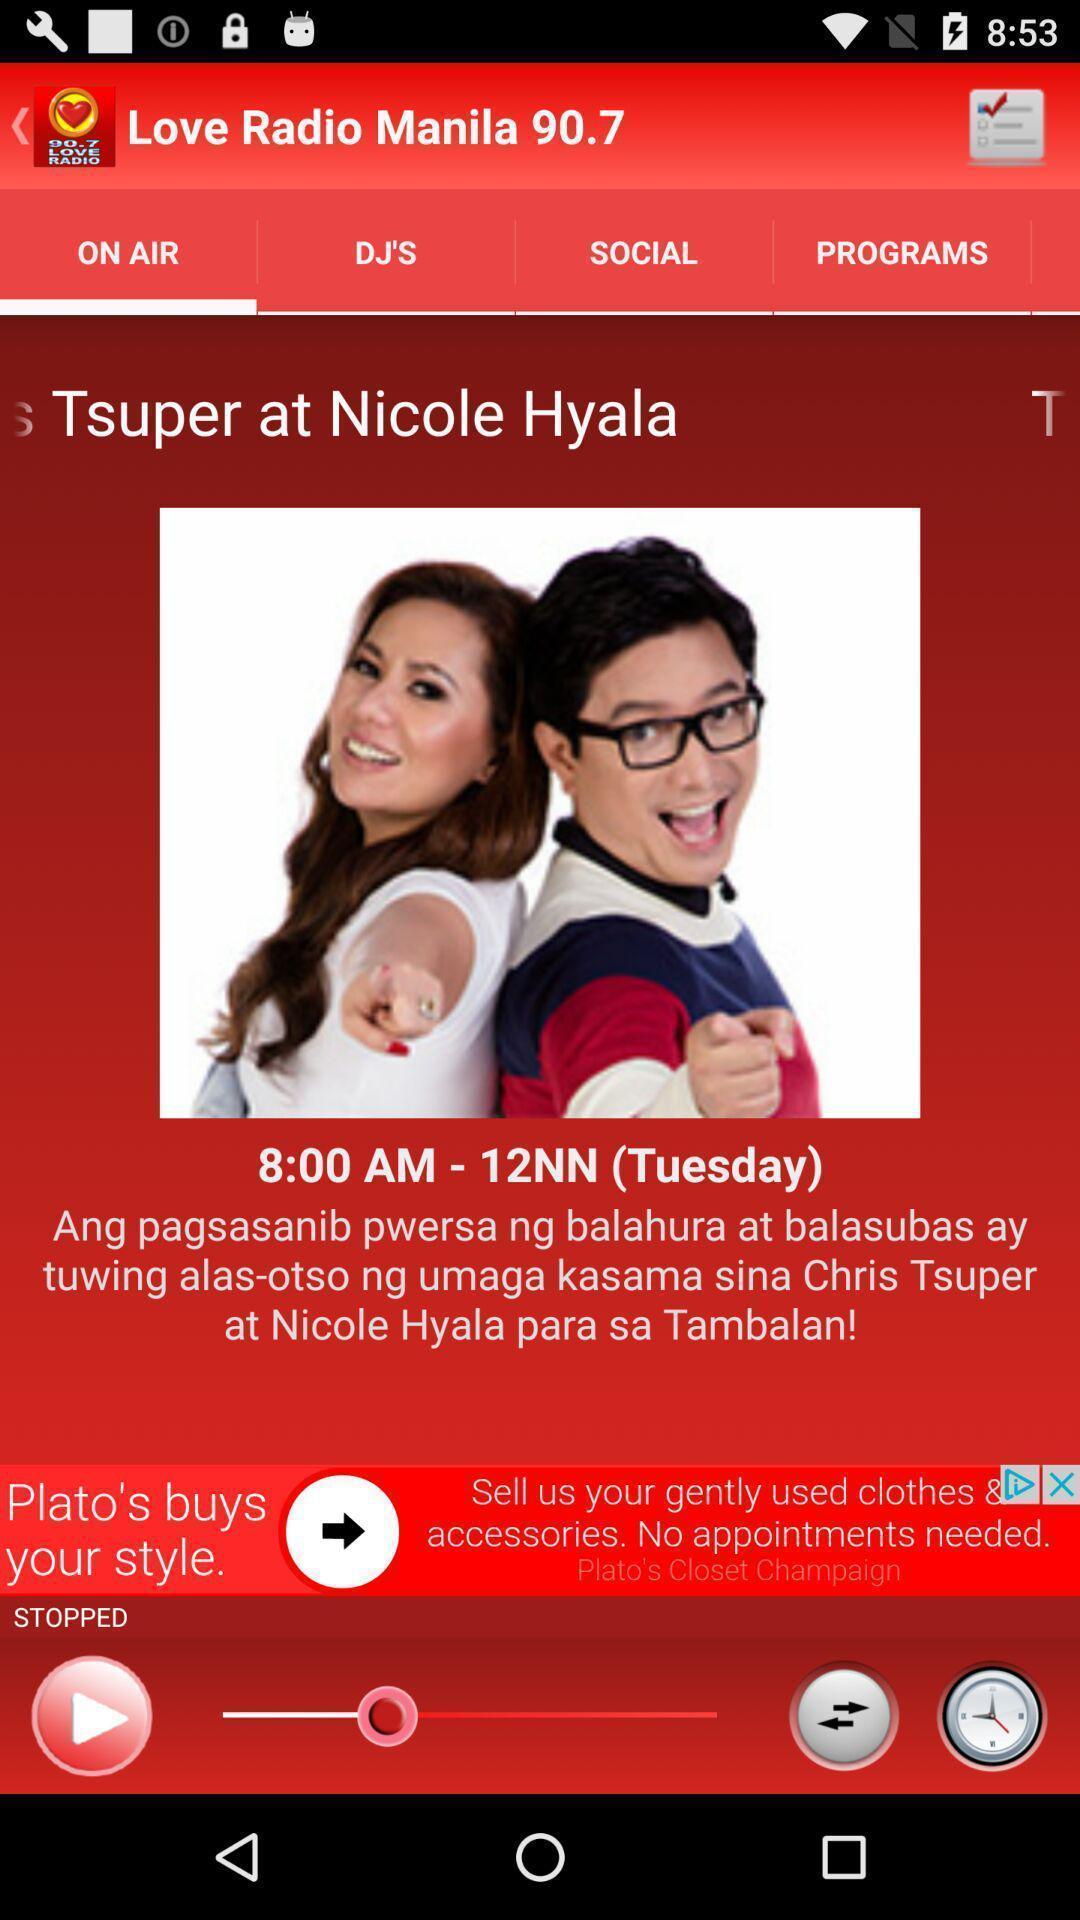Provide a textual representation of this image. Screen shows on air live radio mobile app. 